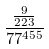Convert formula to latex. <formula><loc_0><loc_0><loc_500><loc_500>\frac { \frac { 9 } { 2 2 3 } } { 7 7 ^ { 4 5 5 } }</formula> 